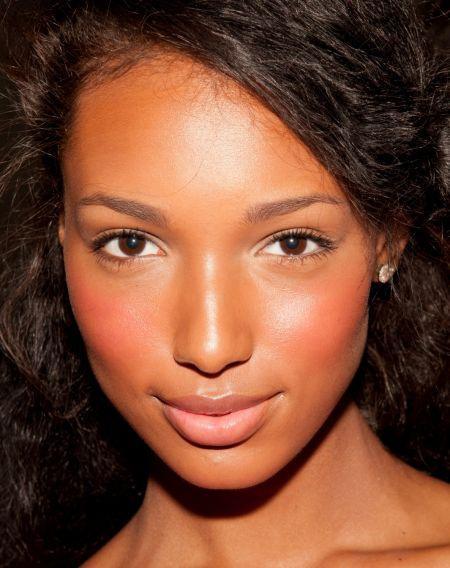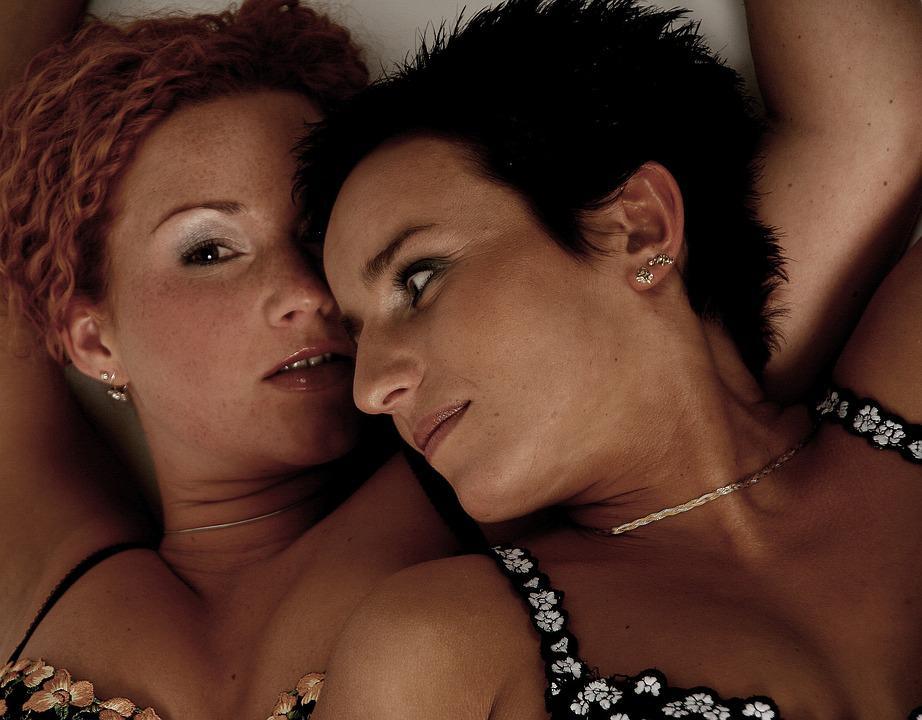The first image is the image on the left, the second image is the image on the right. For the images displayed, is the sentence "There is a lady looking directly at the camera." factually correct? Answer yes or no. Yes. The first image is the image on the left, the second image is the image on the right. Examine the images to the left and right. Is the description "Three people are visible in the two images." accurate? Answer yes or no. Yes. 